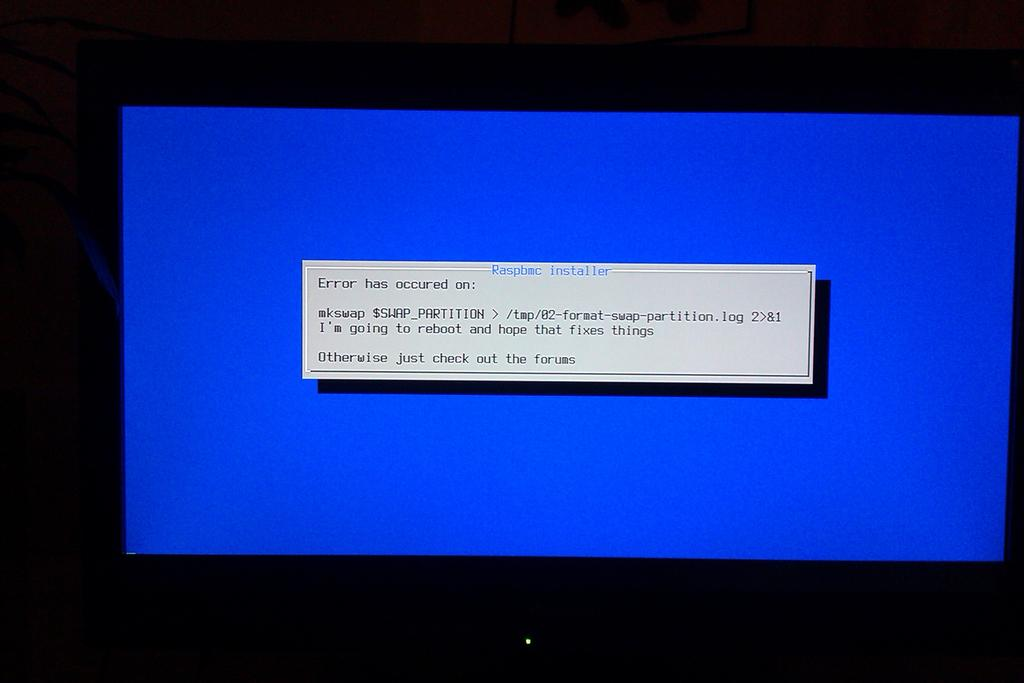<image>
Write a terse but informative summary of the picture. a blue screen on a computer bearing a message beginning with the word error. 